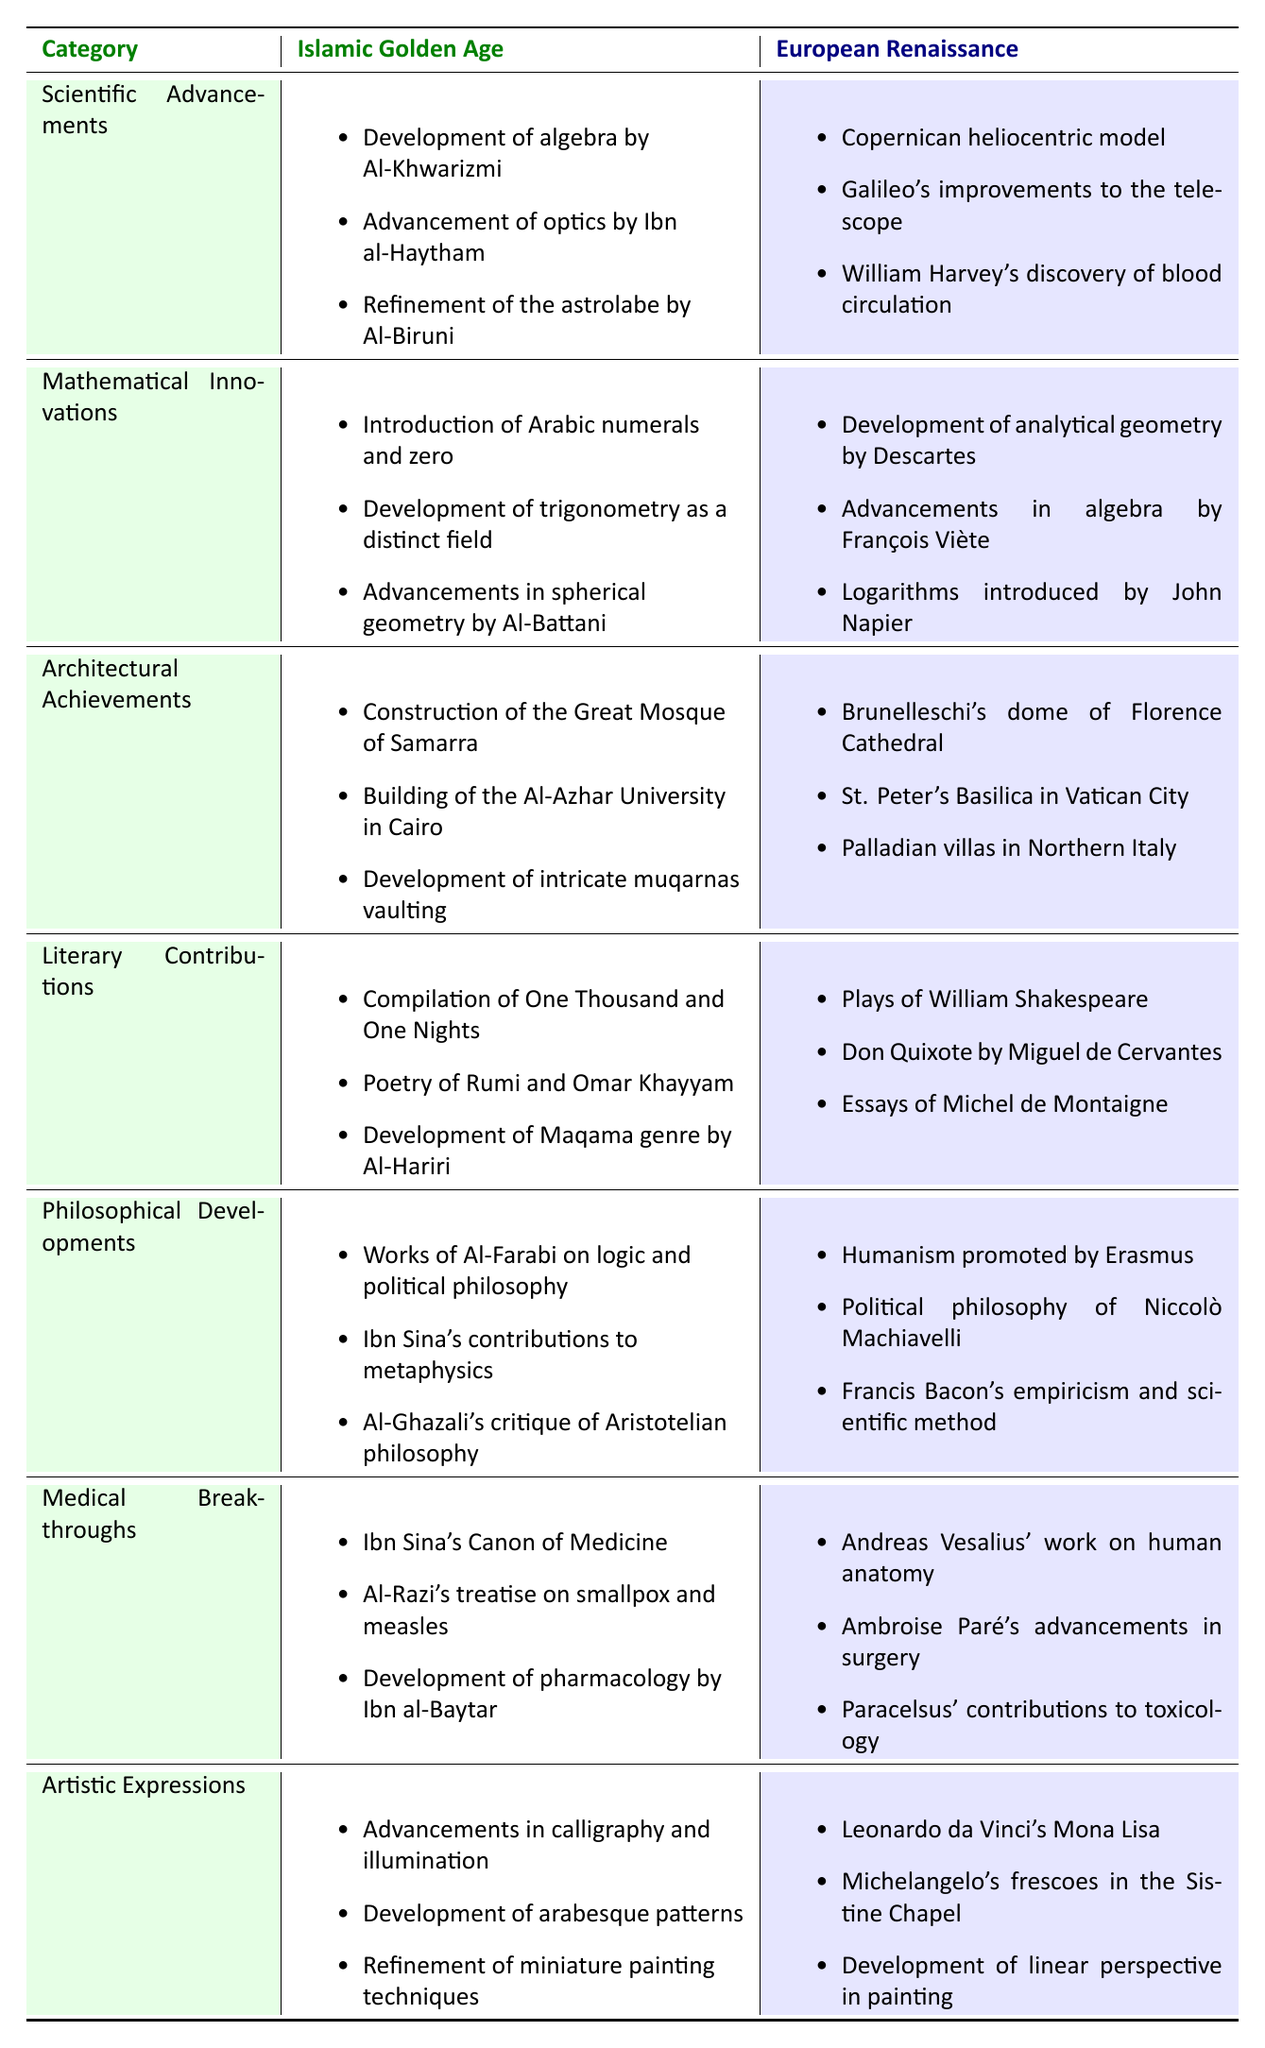What are the achievements in scientific advancements from the Islamic Golden Age? The table lists three specific achievements in the scientific advancements category under the Islamic Golden Age: the development of algebra by Al-Khwarizmi, advancement of optics by Ibn al-Haytham, and refinement of the astrolabe by Al-Biruni.
Answer: Development of algebra, advancement of optics, refinement of the astrolabe Which philosopher’s work critiques Aristotelian philosophy? In the table, under the category of philosophical developments in the Islamic Golden Age, the work that critiques Aristotelian philosophy is attributed to Al-Ghazali.
Answer: Al-Ghazali Did the European Renaissance introduce any significant medical breakthroughs? Yes, the table indicates three significant medical breakthroughs during the European Renaissance: Andreas Vesalius' work on human anatomy, Ambroise Paré's advancements in surgery, and Paracelsus' contributions to toxicology.
Answer: Yes Which era made significant contributions to literary achievements? Both the Islamic Golden Age and the European Renaissance are listed under literary contributions, with the Islamic Golden Age mentioning the compilation of One Thousand and One Nights, poetry of Rumi and Omar Khayyam, and the development of Maqama by Al-Hariri; the European Renaissance includes plays by William Shakespeare, Don Quixote by Miguel de Cervantes, and essays by Michel de Montaigne. Therefore, both eras made significant contributions.
Answer: Both eras What is the difference in the number of achievements listed under architectural achievements between the two eras? For architectural achievements, the Islamic Golden Age has three listed contributions: the construction of the Great Mosque of Samarra, the building of Al-Azhar University, and muqarnas vaulting. The European Renaissance also contains three achievements: Brunelleschi's dome of Florence Cathedral, St. Peter's Basilica, and Palladian villas. Hence, the difference in the number of achievements is 3 - 3 = 0.
Answer: 0 